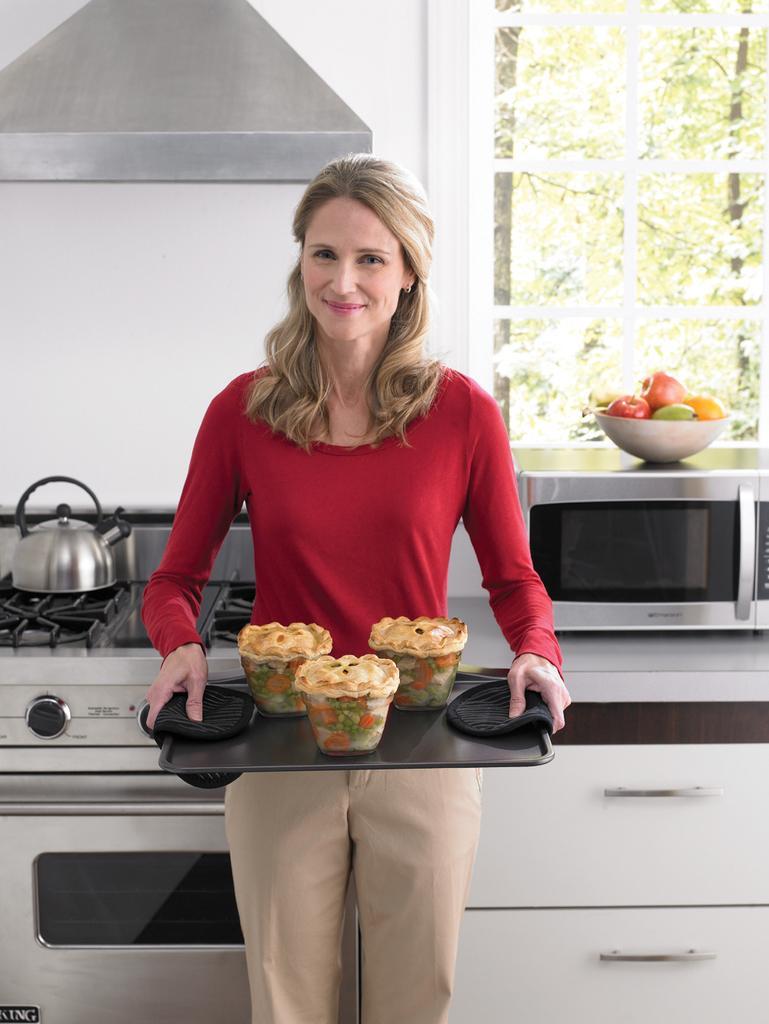How would you summarize this image in a sentence or two? In the middle of the picture, we see the woman in the red T-shirt is standing. She is holding a tray containing three bowls. She is smiling. Behind her, we see the countertop on which microwave oven is placed. We see a bowl containing fruits are placed on the oven. On the left side, we see a gas stove on which kettle is placed. At the top, we see the chimney. In the background, we see a white wall and the glass window from which we can see the trees. 